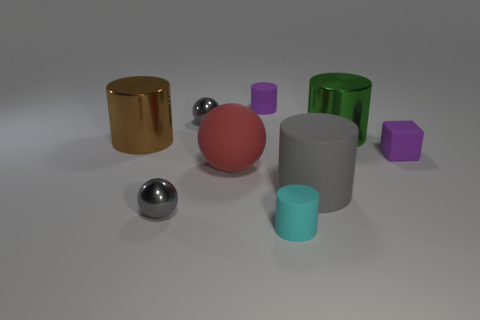Which object stands out the most in terms of color and why? The bright pink sphere stands out most prominently due to its vibrant hue, which contrasts sharply with the more subdued tones of the surrounding objects and the neutral background, drawing immediate visual attention. 